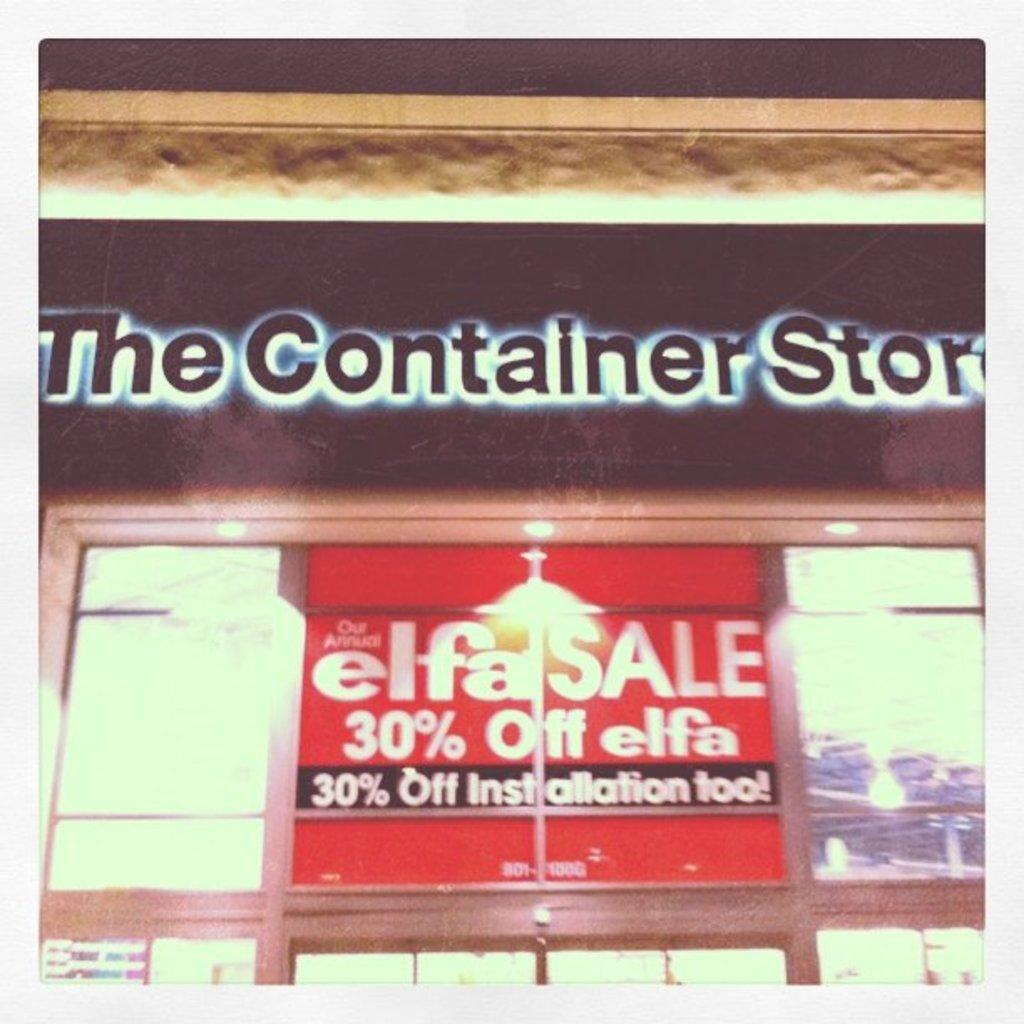<image>
Offer a succinct explanation of the picture presented. The Container Store is having an Elfa Sale with 30% off installation 